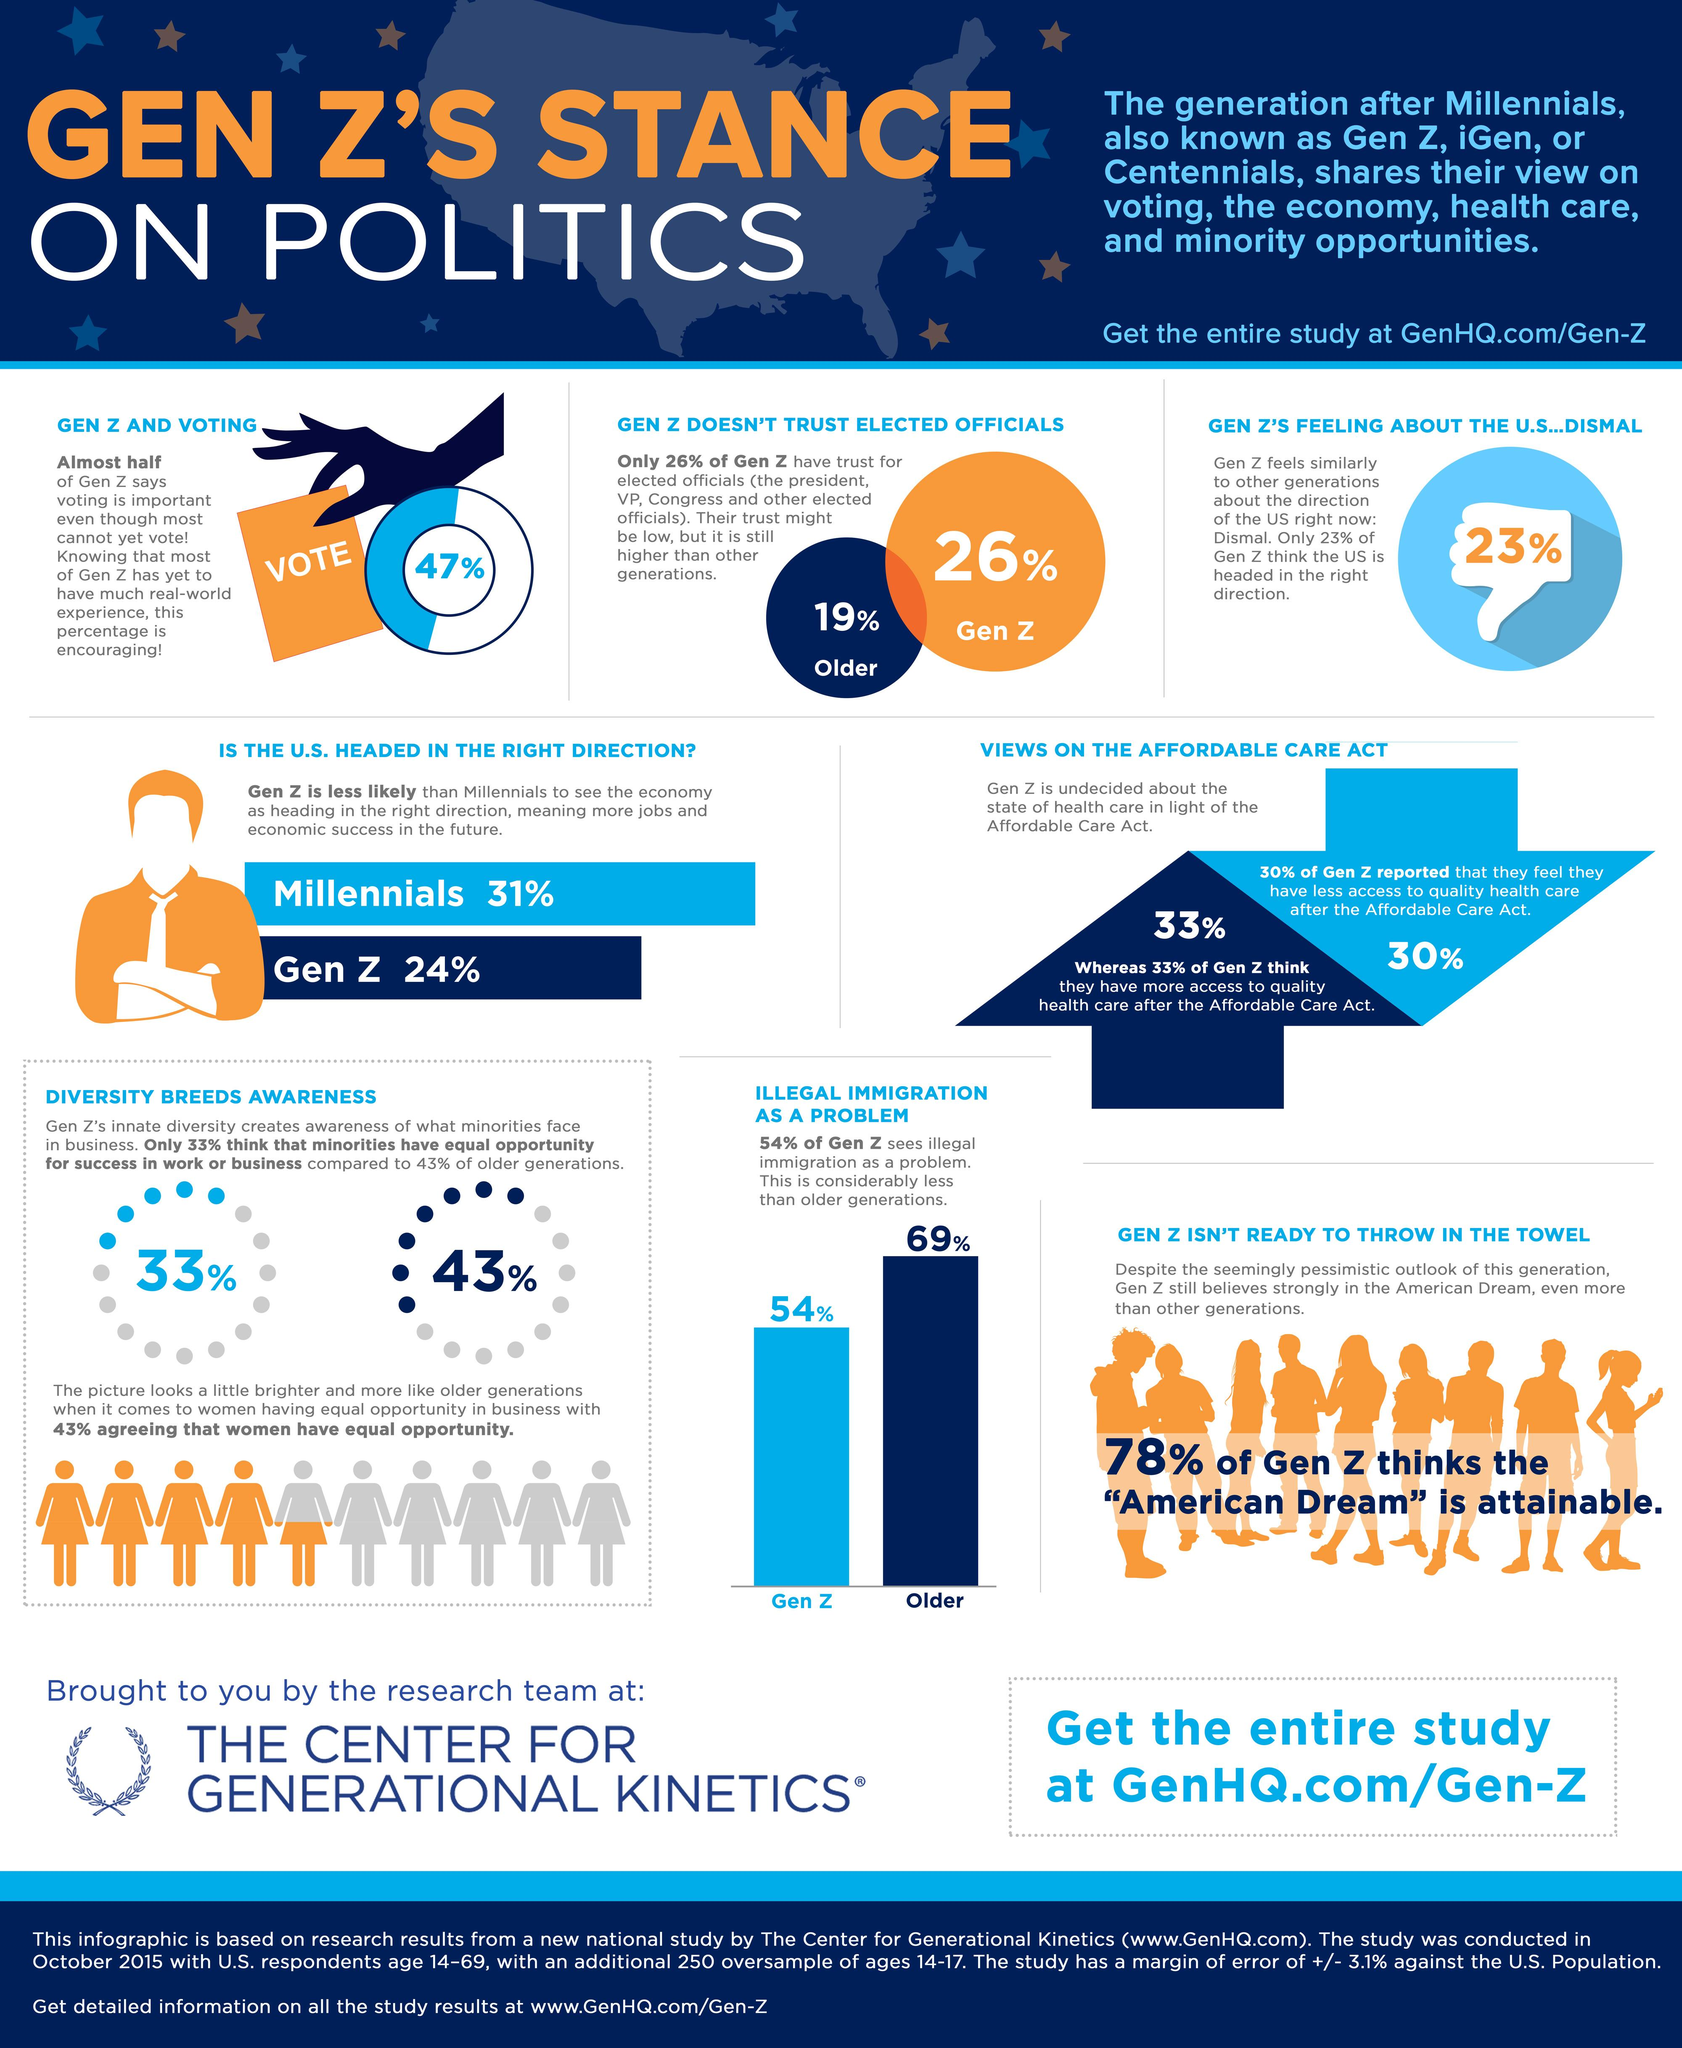List a handful of essential elements in this visual. According to a recent survey, 24% of Gen Z believes that the economy is headed in the right direction. According to a recent survey, 69% of the older generation believes that illegal immigration is a significant problem. According to a recent survey, 43% of the older generation believes that minorities have equal opportunity in society. A recent survey has found that only 19% of the older generation trusts elected officials. 